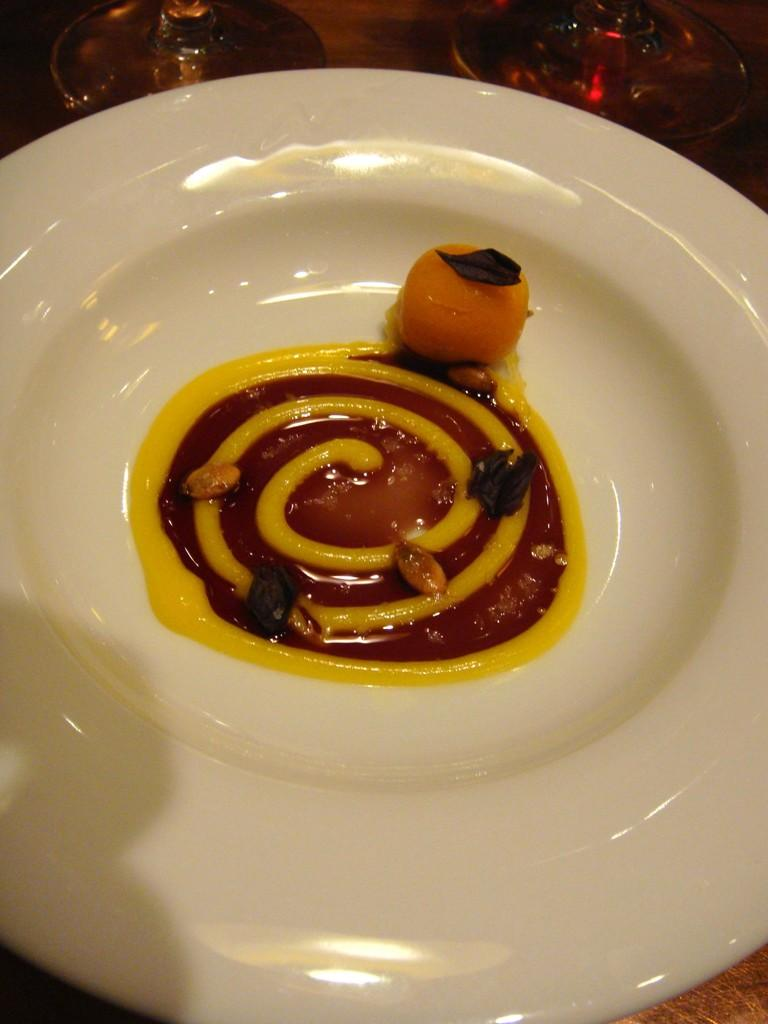What is on the plate that is visible in the image? The plate has a yellow color cream design and dry fruits on it. What other items can be seen in the image besides the plate? There are glasses beside the plate. What type of smoke can be seen coming from the dry fruits on the plate? There is no smoke present in the image; it features a plate with a yellow color cream design and dry fruits on it. 